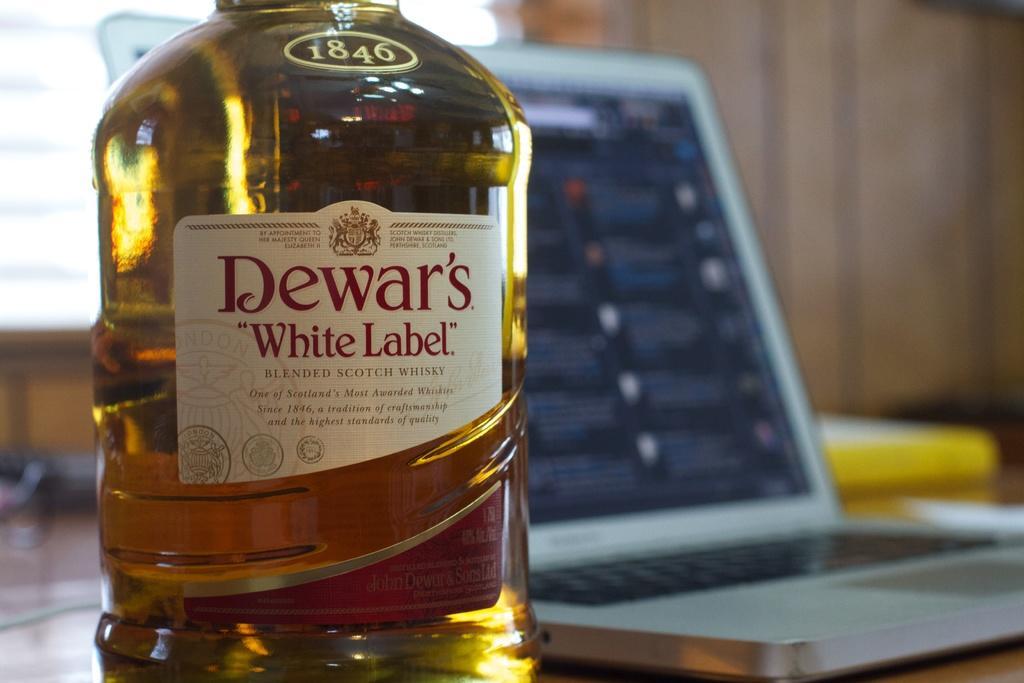Could you give a brief overview of what you see in this image? In this picture we can see bottle with drink in it and sticker to it and aside to this we have laptop and this two are placed on table and in background we can see wall. 